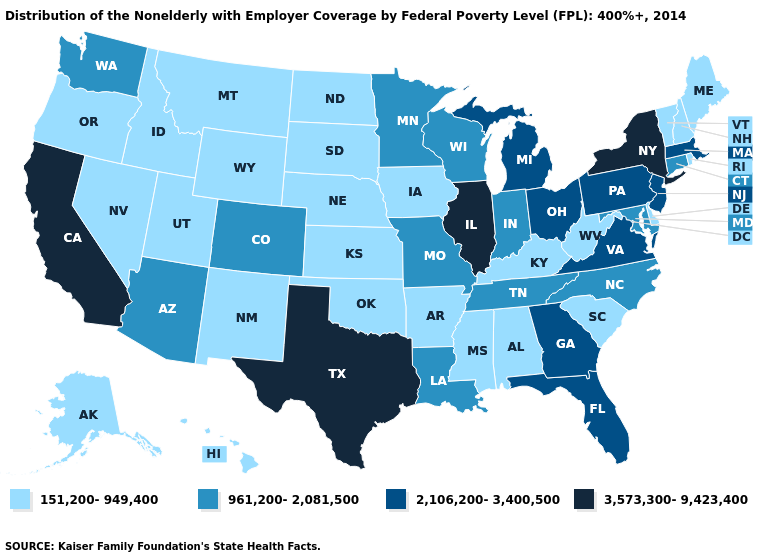Name the states that have a value in the range 151,200-949,400?
Give a very brief answer. Alabama, Alaska, Arkansas, Delaware, Hawaii, Idaho, Iowa, Kansas, Kentucky, Maine, Mississippi, Montana, Nebraska, Nevada, New Hampshire, New Mexico, North Dakota, Oklahoma, Oregon, Rhode Island, South Carolina, South Dakota, Utah, Vermont, West Virginia, Wyoming. Does Nevada have the highest value in the West?
Short answer required. No. Does Tennessee have a lower value than Mississippi?
Give a very brief answer. No. What is the highest value in the MidWest ?
Concise answer only. 3,573,300-9,423,400. Does New Jersey have the same value as Kentucky?
Concise answer only. No. Does Texas have the highest value in the South?
Write a very short answer. Yes. What is the lowest value in states that border Rhode Island?
Give a very brief answer. 961,200-2,081,500. Which states have the lowest value in the Northeast?
Give a very brief answer. Maine, New Hampshire, Rhode Island, Vermont. Which states have the lowest value in the MidWest?
Write a very short answer. Iowa, Kansas, Nebraska, North Dakota, South Dakota. What is the lowest value in the USA?
Concise answer only. 151,200-949,400. Which states have the lowest value in the USA?
Be succinct. Alabama, Alaska, Arkansas, Delaware, Hawaii, Idaho, Iowa, Kansas, Kentucky, Maine, Mississippi, Montana, Nebraska, Nevada, New Hampshire, New Mexico, North Dakota, Oklahoma, Oregon, Rhode Island, South Carolina, South Dakota, Utah, Vermont, West Virginia, Wyoming. Name the states that have a value in the range 961,200-2,081,500?
Concise answer only. Arizona, Colorado, Connecticut, Indiana, Louisiana, Maryland, Minnesota, Missouri, North Carolina, Tennessee, Washington, Wisconsin. What is the value of Michigan?
Keep it brief. 2,106,200-3,400,500. Among the states that border Pennsylvania , which have the highest value?
Quick response, please. New York. Which states hav the highest value in the Northeast?
Short answer required. New York. 